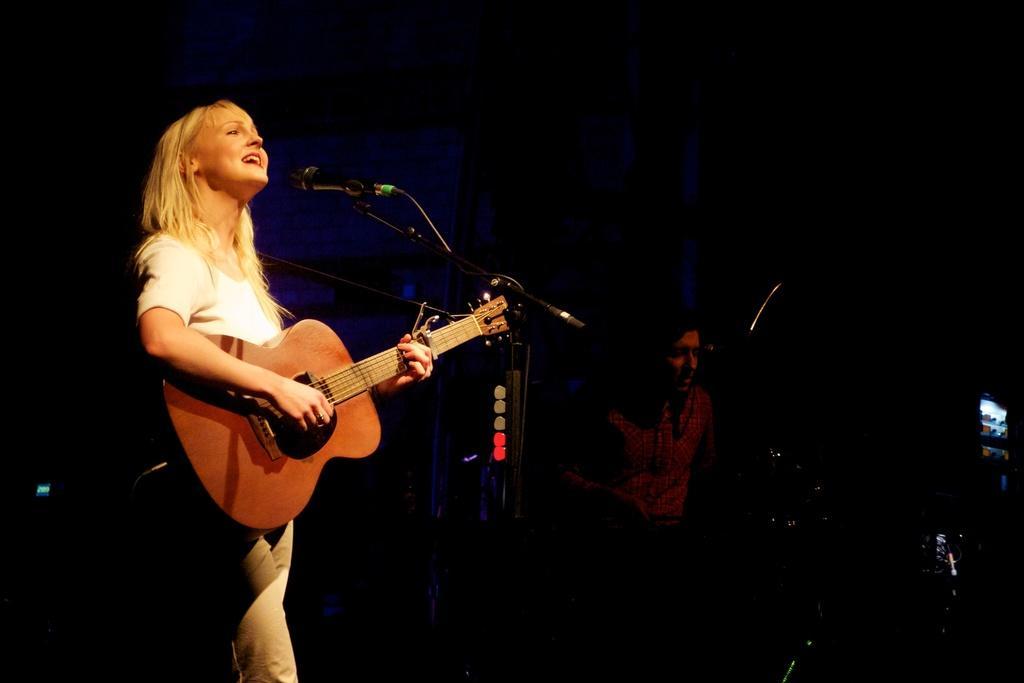Please provide a concise description of this image. In the left, there is a woman standing and singing in front of the mike and playing a guitar. In the right bottom, there is a person is sitting and playing instruments. In the background, the curtain is visible which is black in color and blue in color. It seems the image is taken in a concert stage during night time. 